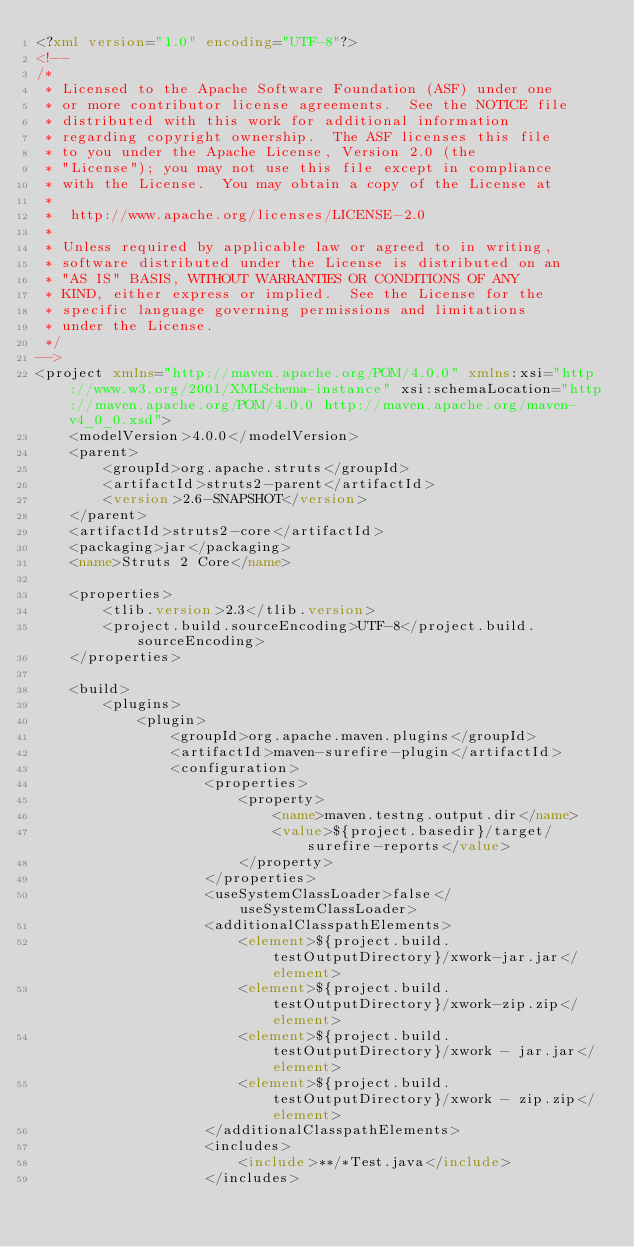<code> <loc_0><loc_0><loc_500><loc_500><_XML_><?xml version="1.0" encoding="UTF-8"?>
<!--
/*
 * Licensed to the Apache Software Foundation (ASF) under one
 * or more contributor license agreements.  See the NOTICE file
 * distributed with this work for additional information
 * regarding copyright ownership.  The ASF licenses this file
 * to you under the Apache License, Version 2.0 (the
 * "License"); you may not use this file except in compliance
 * with the License.  You may obtain a copy of the License at
 *
 *  http://www.apache.org/licenses/LICENSE-2.0
 *
 * Unless required by applicable law or agreed to in writing,
 * software distributed under the License is distributed on an
 * "AS IS" BASIS, WITHOUT WARRANTIES OR CONDITIONS OF ANY
 * KIND, either express or implied.  See the License for the
 * specific language governing permissions and limitations
 * under the License.
 */
-->
<project xmlns="http://maven.apache.org/POM/4.0.0" xmlns:xsi="http://www.w3.org/2001/XMLSchema-instance" xsi:schemaLocation="http://maven.apache.org/POM/4.0.0 http://maven.apache.org/maven-v4_0_0.xsd">
    <modelVersion>4.0.0</modelVersion>
    <parent>
        <groupId>org.apache.struts</groupId>
        <artifactId>struts2-parent</artifactId>
        <version>2.6-SNAPSHOT</version>
    </parent>
    <artifactId>struts2-core</artifactId>
    <packaging>jar</packaging>
    <name>Struts 2 Core</name>

    <properties>
        <tlib.version>2.3</tlib.version>
        <project.build.sourceEncoding>UTF-8</project.build.sourceEncoding>
    </properties>

    <build>
        <plugins>
            <plugin>
                <groupId>org.apache.maven.plugins</groupId>
                <artifactId>maven-surefire-plugin</artifactId>
                <configuration>
                    <properties>
                        <property>
                            <name>maven.testng.output.dir</name>
                            <value>${project.basedir}/target/surefire-reports</value>
                        </property>
                    </properties>
                    <useSystemClassLoader>false</useSystemClassLoader>
                    <additionalClasspathElements>
                        <element>${project.build.testOutputDirectory}/xwork-jar.jar</element>
                        <element>${project.build.testOutputDirectory}/xwork-zip.zip</element>
                        <element>${project.build.testOutputDirectory}/xwork - jar.jar</element>
                        <element>${project.build.testOutputDirectory}/xwork - zip.zip</element>
                    </additionalClasspathElements>
                    <includes>
                        <include>**/*Test.java</include>
                    </includes></code> 